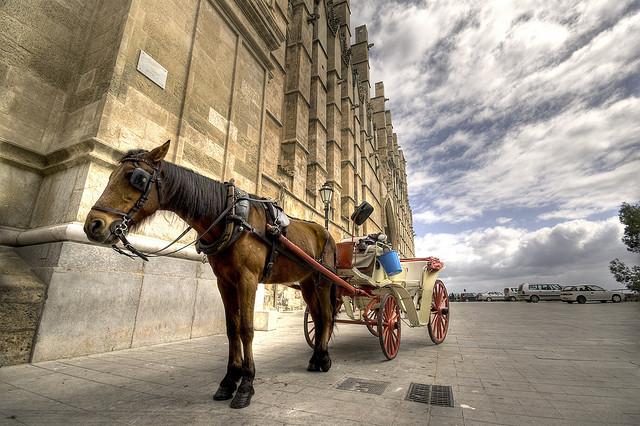What is the blue pail for?
Concise answer only. Water. What is the horse pulling?
Quick response, please. Carriage. What kind of animal is pulling the cart?
Concise answer only. Horse. 